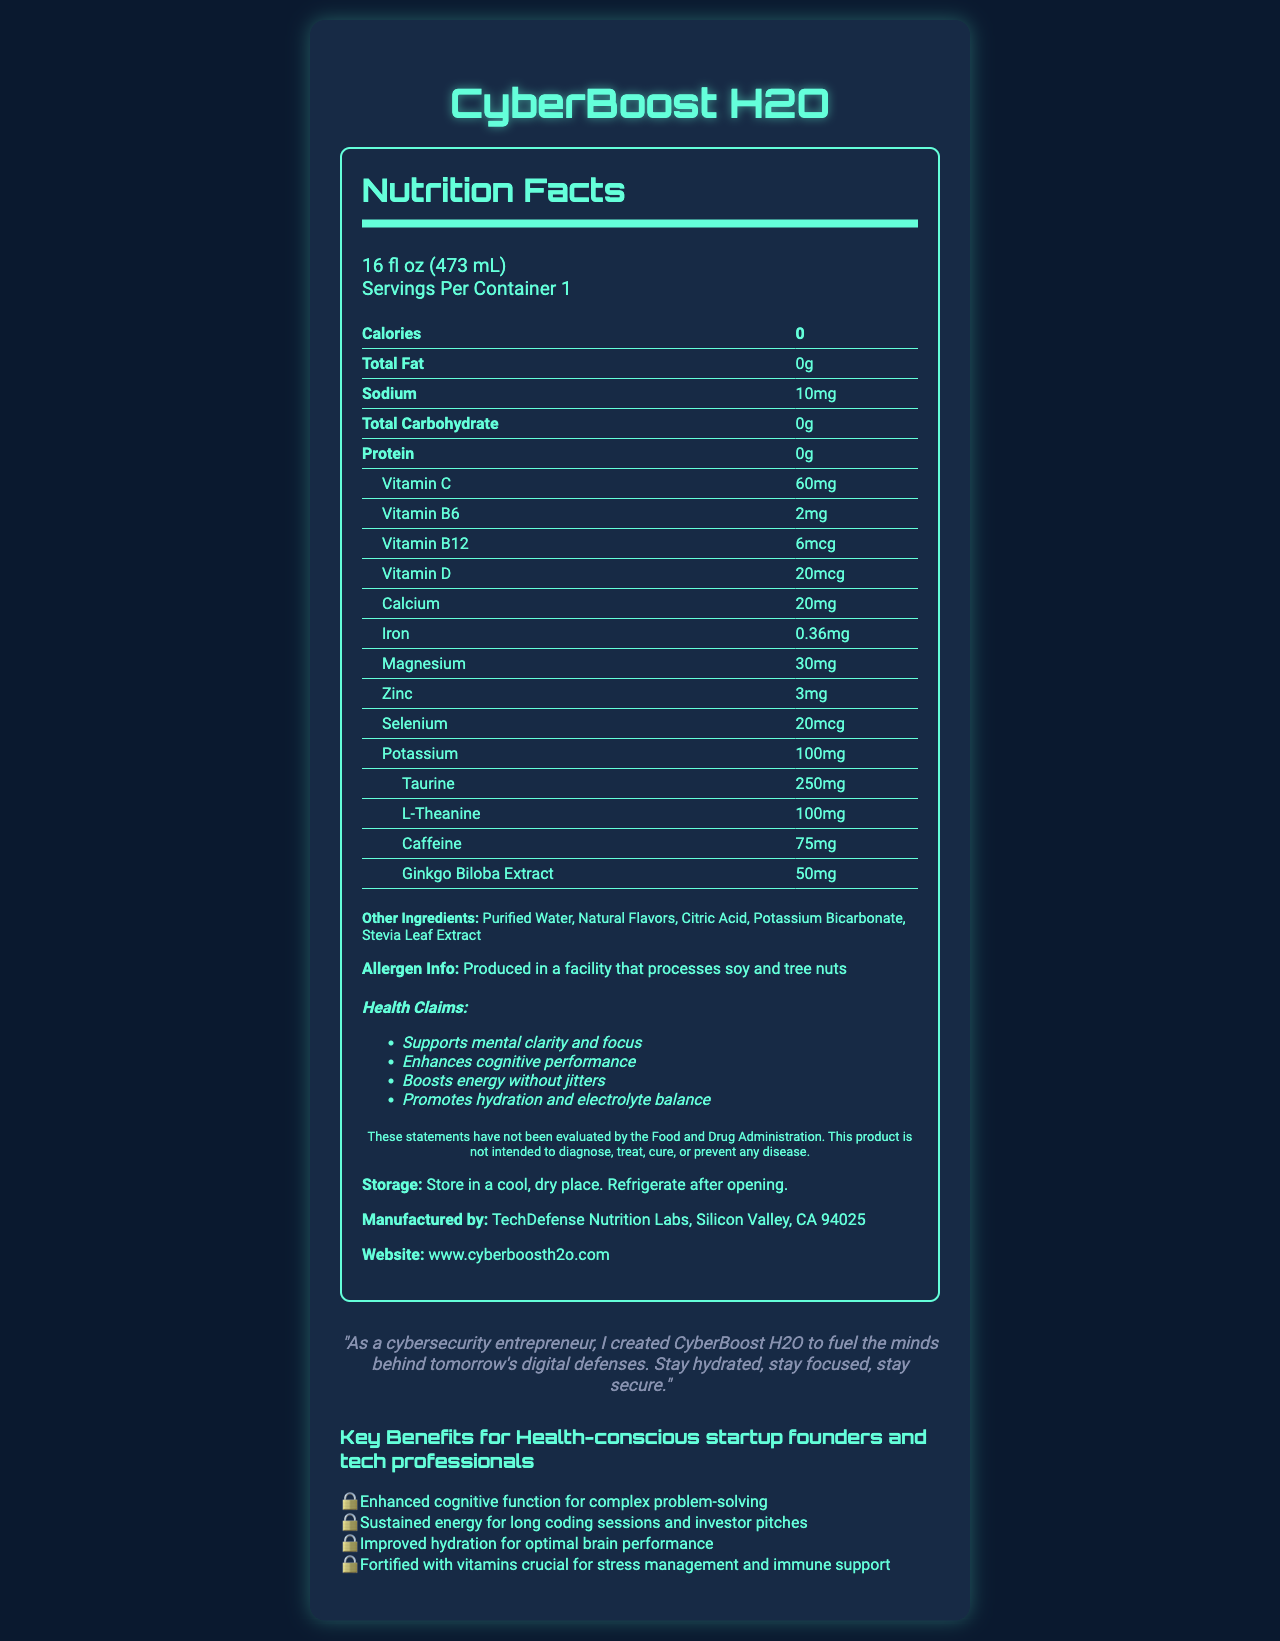What is the serving size of CyberBoost H2O? The serving size is listed at the top of the nutrition facts section and is specified as "16 fl oz (473 mL)".
Answer: 16 fl oz (473 mL) How many servings are in a container of CyberBoost H2O? "Servings Per Container" is listed as 1 in the nutrition facts section.
Answer: 1 How much caffeine does CyberBoost H2O contain? The amount of caffeine is listed in the ingredients table as 75mg.
Answer: 75mg What vitamins and minerals are included in CyberBoost H2O? The document lists these vitamins and minerals under the nutrition facts section.
Answer: Vitamin C, Vitamin B6, Vitamin B12, Vitamin D, Calcium, Iron, Magnesium, Zinc, Selenium, Potassium Which claim about CyberBoost H2O is included? It is stated in the health claims section of the document.
Answer: Boosts energy without jitters Which of the following vitamins is NOT found in CyberBoost H2O? A. Vitamin A B. Vitamin C C. Vitamin D D. Vitamin B6 The nutrition facts section lists Vitamin C, B6, B12, and D but not Vitamin A.
Answer: A. Vitamin A What is the main source of sweetness in CyberBoost H2O? A. Sugar B. Stevia Leaf Extract C. Aspartame D. Honey The "Other Ingredients" section lists Stevia Leaf Extract as an ingredient, suggesting it is the source of sweetness.
Answer: B. Stevia Leaf Extract Does CyberBoost H2O contain any calories? The nutrition facts state "Calories: 0".
Answer: No Does the product contain any allergens? The allergen info specifies that it is produced in a facility that processes soy and tree nuts.
Answer: Yes Summarize the main idea of the document. The document provides comprehensive details about CyberBoost H2O, including its nutritional content, health claims, and benefits geared towards tech professionals. It also includes storage instructions, manufacturing details, and a testimonial from the founder.
Answer: CyberBoost H2O is a vitamin-fortified bottled water designed for health-conscious startup founders and tech professionals. It supports mental clarity and focus, enhances cognitive performance, boosts energy without jitters, and promotes hydration. Who is the manufacturer of CyberBoost H2O? The document states that the product is manufactured by TechDefense Nutrition Labs, Silicon Valley, CA 94025.
Answer: TechDefense Nutrition Labs, Silicon Valley, CA 94025 What is the website for more information about CyberBoost H2O? The document includes the manufacturer's website at the bottom of the nutrition facts section.
Answer: www.cyberboosth2o.com How much Taurine is present in CyberBoost H2O? The amount of Taurine is listed in the ingredients table as 250mg.
Answer: 250mg Which of these benefits is NOT listed for CyberBoost H2O? A. Enhanced cognitive function for complex problem-solving B. Improved muscle development C. Sustained energy for long coding sessions and investor pitches D. Improved hydration for optimal brain performance The document lists benefits related to cognitive function, energy sustenance, and hydration but not muscle development.
Answer: B. Improved muscle development Does CyberBoost H2O's label include a disclaimer about FDA evaluation? The disclaimer in the document states that the claims have not been evaluated by the Food and Drug Administration (FDA).
Answer: Yes What is the founder's testimonial about CyberBoost H2O? The testimonial is stated clearly in the document under the founder testimonial section.
Answer: "As a cybersecurity entrepreneur, I created CyberBoost H2O to fuel the minds behind tomorrow's digital defenses. Stay hydrated, stay focused, stay secure." Which key benefit of CyberBoost H2O is directly related to stress management? This benefit is listed as the last point in the key benefits section.
Answer: Fortified with vitamins crucial for stress management and immune support How should CyberBoost H2O be stored after opening? The storage instructions specify to refrigerate after opening.
Answer: Refrigerate after opening What is the purpose of adding L-Theanine in CyberBoost H2O? The document lists L-Theanine as an ingredient but does not specify its purpose.
Answer: Cannot be determined Does CyberBoost H2O have any fat content? The nutrition facts section states that the Total Fat content is 0g.
Answer: No 